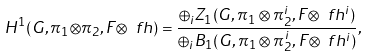Convert formula to latex. <formula><loc_0><loc_0><loc_500><loc_500>H ^ { 1 } ( G , { \pi _ { 1 } } { \otimes } \pi _ { 2 } , F { \otimes } \ f h ) = \frac { \oplus _ { i } Z _ { 1 } ( G , \pi _ { 1 } \otimes \pi ^ { i } _ { 2 } , F { \otimes } \ f h ^ { i } ) } { \oplus _ { i } B _ { 1 } ( G , \pi _ { 1 } \otimes \pi ^ { i } _ { 2 } , F { \otimes } \ f h ^ { i } ) } ,</formula> 